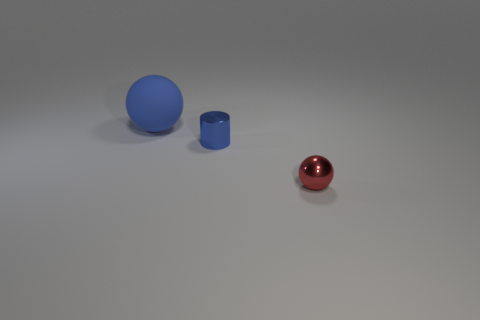Are there any other things that are the same size as the rubber thing?
Provide a short and direct response. No. There is a object that is made of the same material as the red ball; what shape is it?
Provide a short and direct response. Cylinder. Is the size of the blue metallic cylinder the same as the red sphere?
Give a very brief answer. Yes. Do the sphere behind the metal ball and the blue cylinder have the same material?
Keep it short and to the point. No. Are there any other things that are made of the same material as the blue ball?
Offer a very short reply. No. There is a blue object on the right side of the ball that is behind the tiny blue shiny object; what number of blue matte things are in front of it?
Give a very brief answer. 0. Is the shape of the small metal thing that is in front of the blue cylinder the same as  the big blue matte object?
Provide a succinct answer. Yes. What number of objects are green rubber objects or things on the left side of the small metal sphere?
Offer a very short reply. 2. Are there more tiny shiny things left of the big blue ball than tiny red balls?
Keep it short and to the point. No. Are there the same number of small blue cylinders in front of the small red metallic thing and blue matte balls behind the big ball?
Provide a short and direct response. Yes. 